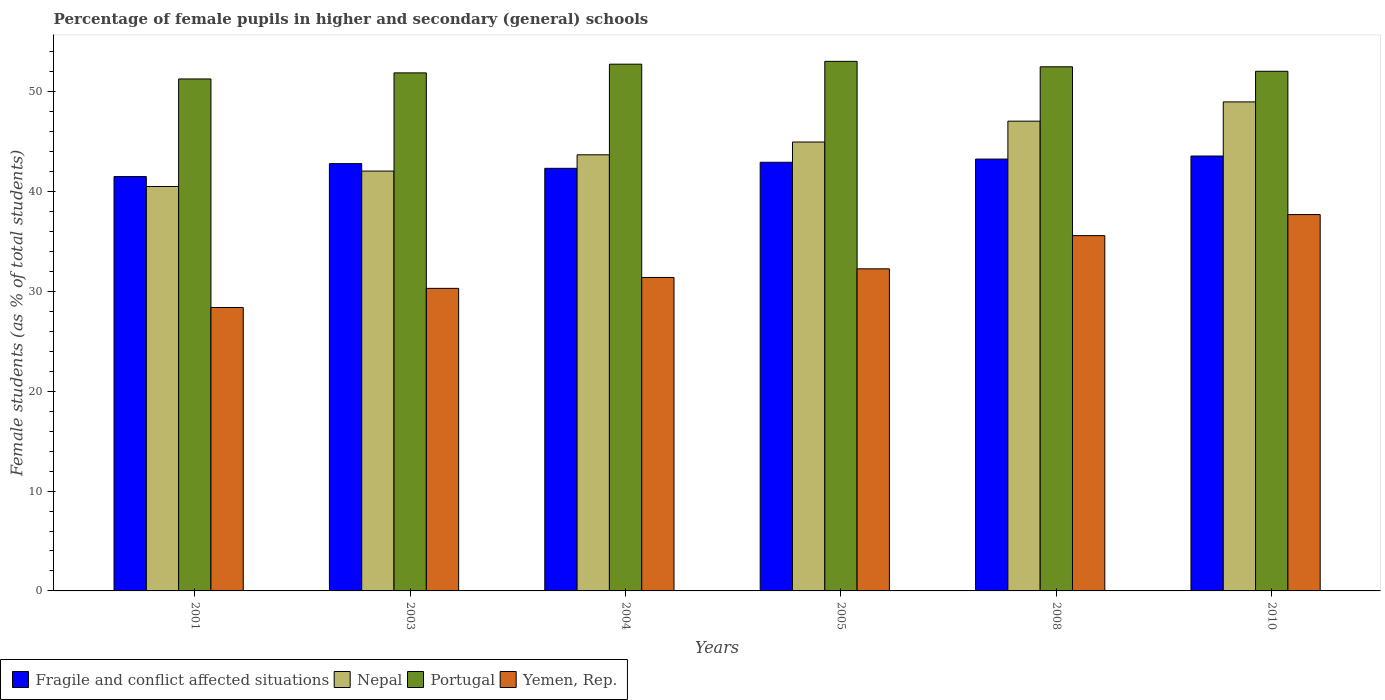How many different coloured bars are there?
Your response must be concise. 4. How many groups of bars are there?
Offer a terse response. 6. How many bars are there on the 3rd tick from the left?
Give a very brief answer. 4. How many bars are there on the 3rd tick from the right?
Offer a terse response. 4. What is the percentage of female pupils in higher and secondary schools in Nepal in 2003?
Ensure brevity in your answer.  42.04. Across all years, what is the maximum percentage of female pupils in higher and secondary schools in Nepal?
Offer a terse response. 48.97. Across all years, what is the minimum percentage of female pupils in higher and secondary schools in Nepal?
Your response must be concise. 40.5. In which year was the percentage of female pupils in higher and secondary schools in Nepal maximum?
Provide a short and direct response. 2010. What is the total percentage of female pupils in higher and secondary schools in Yemen, Rep. in the graph?
Provide a short and direct response. 195.58. What is the difference between the percentage of female pupils in higher and secondary schools in Yemen, Rep. in 2003 and that in 2010?
Offer a terse response. -7.39. What is the difference between the percentage of female pupils in higher and secondary schools in Yemen, Rep. in 2010 and the percentage of female pupils in higher and secondary schools in Portugal in 2005?
Ensure brevity in your answer.  -15.34. What is the average percentage of female pupils in higher and secondary schools in Yemen, Rep. per year?
Keep it short and to the point. 32.6. In the year 2010, what is the difference between the percentage of female pupils in higher and secondary schools in Nepal and percentage of female pupils in higher and secondary schools in Yemen, Rep.?
Offer a terse response. 11.28. In how many years, is the percentage of female pupils in higher and secondary schools in Fragile and conflict affected situations greater than 26 %?
Keep it short and to the point. 6. What is the ratio of the percentage of female pupils in higher and secondary schools in Nepal in 2003 to that in 2008?
Offer a very short reply. 0.89. What is the difference between the highest and the second highest percentage of female pupils in higher and secondary schools in Nepal?
Offer a very short reply. 1.93. What is the difference between the highest and the lowest percentage of female pupils in higher and secondary schools in Portugal?
Ensure brevity in your answer.  1.76. In how many years, is the percentage of female pupils in higher and secondary schools in Portugal greater than the average percentage of female pupils in higher and secondary schools in Portugal taken over all years?
Provide a succinct answer. 3. What does the 4th bar from the left in 2008 represents?
Provide a short and direct response. Yemen, Rep. What does the 1st bar from the right in 2010 represents?
Offer a terse response. Yemen, Rep. Is it the case that in every year, the sum of the percentage of female pupils in higher and secondary schools in Nepal and percentage of female pupils in higher and secondary schools in Fragile and conflict affected situations is greater than the percentage of female pupils in higher and secondary schools in Portugal?
Provide a short and direct response. Yes. How many bars are there?
Your response must be concise. 24. Are all the bars in the graph horizontal?
Offer a terse response. No. How many years are there in the graph?
Your answer should be very brief. 6. Are the values on the major ticks of Y-axis written in scientific E-notation?
Keep it short and to the point. No. Does the graph contain grids?
Your response must be concise. No. What is the title of the graph?
Offer a very short reply. Percentage of female pupils in higher and secondary (general) schools. Does "Afghanistan" appear as one of the legend labels in the graph?
Provide a succinct answer. No. What is the label or title of the X-axis?
Your answer should be very brief. Years. What is the label or title of the Y-axis?
Provide a short and direct response. Female students (as % of total students). What is the Female students (as % of total students) of Fragile and conflict affected situations in 2001?
Provide a short and direct response. 41.49. What is the Female students (as % of total students) of Nepal in 2001?
Make the answer very short. 40.5. What is the Female students (as % of total students) of Portugal in 2001?
Ensure brevity in your answer.  51.26. What is the Female students (as % of total students) of Yemen, Rep. in 2001?
Provide a succinct answer. 28.38. What is the Female students (as % of total students) in Fragile and conflict affected situations in 2003?
Your answer should be very brief. 42.79. What is the Female students (as % of total students) of Nepal in 2003?
Provide a short and direct response. 42.04. What is the Female students (as % of total students) of Portugal in 2003?
Keep it short and to the point. 51.87. What is the Female students (as % of total students) in Yemen, Rep. in 2003?
Give a very brief answer. 30.3. What is the Female students (as % of total students) of Fragile and conflict affected situations in 2004?
Keep it short and to the point. 42.32. What is the Female students (as % of total students) in Nepal in 2004?
Your answer should be compact. 43.67. What is the Female students (as % of total students) of Portugal in 2004?
Keep it short and to the point. 52.74. What is the Female students (as % of total students) of Yemen, Rep. in 2004?
Keep it short and to the point. 31.39. What is the Female students (as % of total students) in Fragile and conflict affected situations in 2005?
Give a very brief answer. 42.92. What is the Female students (as % of total students) of Nepal in 2005?
Your response must be concise. 44.95. What is the Female students (as % of total students) in Portugal in 2005?
Provide a succinct answer. 53.03. What is the Female students (as % of total students) in Yemen, Rep. in 2005?
Your response must be concise. 32.25. What is the Female students (as % of total students) in Fragile and conflict affected situations in 2008?
Your answer should be compact. 43.24. What is the Female students (as % of total students) of Nepal in 2008?
Offer a very short reply. 47.04. What is the Female students (as % of total students) in Portugal in 2008?
Keep it short and to the point. 52.48. What is the Female students (as % of total students) of Yemen, Rep. in 2008?
Ensure brevity in your answer.  35.58. What is the Female students (as % of total students) of Fragile and conflict affected situations in 2010?
Offer a terse response. 43.55. What is the Female students (as % of total students) in Nepal in 2010?
Ensure brevity in your answer.  48.97. What is the Female students (as % of total students) of Portugal in 2010?
Keep it short and to the point. 52.03. What is the Female students (as % of total students) in Yemen, Rep. in 2010?
Provide a succinct answer. 37.69. Across all years, what is the maximum Female students (as % of total students) in Fragile and conflict affected situations?
Provide a succinct answer. 43.55. Across all years, what is the maximum Female students (as % of total students) of Nepal?
Your answer should be compact. 48.97. Across all years, what is the maximum Female students (as % of total students) in Portugal?
Give a very brief answer. 53.03. Across all years, what is the maximum Female students (as % of total students) of Yemen, Rep.?
Your response must be concise. 37.69. Across all years, what is the minimum Female students (as % of total students) in Fragile and conflict affected situations?
Your answer should be compact. 41.49. Across all years, what is the minimum Female students (as % of total students) of Nepal?
Your answer should be very brief. 40.5. Across all years, what is the minimum Female students (as % of total students) in Portugal?
Offer a terse response. 51.26. Across all years, what is the minimum Female students (as % of total students) in Yemen, Rep.?
Give a very brief answer. 28.38. What is the total Female students (as % of total students) of Fragile and conflict affected situations in the graph?
Ensure brevity in your answer.  256.31. What is the total Female students (as % of total students) of Nepal in the graph?
Ensure brevity in your answer.  267.16. What is the total Female students (as % of total students) in Portugal in the graph?
Make the answer very short. 313.43. What is the total Female students (as % of total students) in Yemen, Rep. in the graph?
Offer a terse response. 195.58. What is the difference between the Female students (as % of total students) in Fragile and conflict affected situations in 2001 and that in 2003?
Provide a succinct answer. -1.29. What is the difference between the Female students (as % of total students) of Nepal in 2001 and that in 2003?
Provide a succinct answer. -1.54. What is the difference between the Female students (as % of total students) in Portugal in 2001 and that in 2003?
Provide a succinct answer. -0.61. What is the difference between the Female students (as % of total students) in Yemen, Rep. in 2001 and that in 2003?
Provide a short and direct response. -1.92. What is the difference between the Female students (as % of total students) in Fragile and conflict affected situations in 2001 and that in 2004?
Ensure brevity in your answer.  -0.82. What is the difference between the Female students (as % of total students) in Nepal in 2001 and that in 2004?
Provide a succinct answer. -3.17. What is the difference between the Female students (as % of total students) in Portugal in 2001 and that in 2004?
Ensure brevity in your answer.  -1.48. What is the difference between the Female students (as % of total students) in Yemen, Rep. in 2001 and that in 2004?
Offer a terse response. -3.01. What is the difference between the Female students (as % of total students) in Fragile and conflict affected situations in 2001 and that in 2005?
Your answer should be very brief. -1.43. What is the difference between the Female students (as % of total students) in Nepal in 2001 and that in 2005?
Ensure brevity in your answer.  -4.45. What is the difference between the Female students (as % of total students) of Portugal in 2001 and that in 2005?
Make the answer very short. -1.76. What is the difference between the Female students (as % of total students) of Yemen, Rep. in 2001 and that in 2005?
Offer a very short reply. -3.87. What is the difference between the Female students (as % of total students) of Fragile and conflict affected situations in 2001 and that in 2008?
Your response must be concise. -1.75. What is the difference between the Female students (as % of total students) in Nepal in 2001 and that in 2008?
Provide a short and direct response. -6.54. What is the difference between the Female students (as % of total students) of Portugal in 2001 and that in 2008?
Your response must be concise. -1.22. What is the difference between the Female students (as % of total students) of Yemen, Rep. in 2001 and that in 2008?
Give a very brief answer. -7.2. What is the difference between the Female students (as % of total students) of Fragile and conflict affected situations in 2001 and that in 2010?
Offer a terse response. -2.06. What is the difference between the Female students (as % of total students) of Nepal in 2001 and that in 2010?
Offer a terse response. -8.47. What is the difference between the Female students (as % of total students) of Portugal in 2001 and that in 2010?
Your response must be concise. -0.77. What is the difference between the Female students (as % of total students) in Yemen, Rep. in 2001 and that in 2010?
Your response must be concise. -9.31. What is the difference between the Female students (as % of total students) of Fragile and conflict affected situations in 2003 and that in 2004?
Offer a very short reply. 0.47. What is the difference between the Female students (as % of total students) of Nepal in 2003 and that in 2004?
Your answer should be very brief. -1.63. What is the difference between the Female students (as % of total students) of Portugal in 2003 and that in 2004?
Your answer should be very brief. -0.87. What is the difference between the Female students (as % of total students) of Yemen, Rep. in 2003 and that in 2004?
Give a very brief answer. -1.09. What is the difference between the Female students (as % of total students) in Fragile and conflict affected situations in 2003 and that in 2005?
Provide a short and direct response. -0.13. What is the difference between the Female students (as % of total students) in Nepal in 2003 and that in 2005?
Keep it short and to the point. -2.91. What is the difference between the Female students (as % of total students) in Portugal in 2003 and that in 2005?
Keep it short and to the point. -1.15. What is the difference between the Female students (as % of total students) in Yemen, Rep. in 2003 and that in 2005?
Offer a terse response. -1.96. What is the difference between the Female students (as % of total students) of Fragile and conflict affected situations in 2003 and that in 2008?
Keep it short and to the point. -0.46. What is the difference between the Female students (as % of total students) of Nepal in 2003 and that in 2008?
Your answer should be compact. -5. What is the difference between the Female students (as % of total students) of Portugal in 2003 and that in 2008?
Make the answer very short. -0.61. What is the difference between the Female students (as % of total students) of Yemen, Rep. in 2003 and that in 2008?
Offer a very short reply. -5.28. What is the difference between the Female students (as % of total students) of Fragile and conflict affected situations in 2003 and that in 2010?
Your answer should be very brief. -0.76. What is the difference between the Female students (as % of total students) in Nepal in 2003 and that in 2010?
Ensure brevity in your answer.  -6.93. What is the difference between the Female students (as % of total students) in Portugal in 2003 and that in 2010?
Provide a short and direct response. -0.16. What is the difference between the Female students (as % of total students) in Yemen, Rep. in 2003 and that in 2010?
Your response must be concise. -7.39. What is the difference between the Female students (as % of total students) of Fragile and conflict affected situations in 2004 and that in 2005?
Your answer should be compact. -0.6. What is the difference between the Female students (as % of total students) of Nepal in 2004 and that in 2005?
Offer a terse response. -1.28. What is the difference between the Female students (as % of total students) in Portugal in 2004 and that in 2005?
Your response must be concise. -0.28. What is the difference between the Female students (as % of total students) of Yemen, Rep. in 2004 and that in 2005?
Your answer should be very brief. -0.86. What is the difference between the Female students (as % of total students) of Fragile and conflict affected situations in 2004 and that in 2008?
Your answer should be very brief. -0.93. What is the difference between the Female students (as % of total students) in Nepal in 2004 and that in 2008?
Offer a very short reply. -3.37. What is the difference between the Female students (as % of total students) in Portugal in 2004 and that in 2008?
Keep it short and to the point. 0.26. What is the difference between the Female students (as % of total students) in Yemen, Rep. in 2004 and that in 2008?
Keep it short and to the point. -4.19. What is the difference between the Female students (as % of total students) of Fragile and conflict affected situations in 2004 and that in 2010?
Make the answer very short. -1.23. What is the difference between the Female students (as % of total students) of Nepal in 2004 and that in 2010?
Provide a short and direct response. -5.3. What is the difference between the Female students (as % of total students) in Portugal in 2004 and that in 2010?
Your answer should be compact. 0.71. What is the difference between the Female students (as % of total students) in Yemen, Rep. in 2004 and that in 2010?
Offer a very short reply. -6.3. What is the difference between the Female students (as % of total students) of Fragile and conflict affected situations in 2005 and that in 2008?
Ensure brevity in your answer.  -0.32. What is the difference between the Female students (as % of total students) in Nepal in 2005 and that in 2008?
Provide a short and direct response. -2.09. What is the difference between the Female students (as % of total students) of Portugal in 2005 and that in 2008?
Keep it short and to the point. 0.54. What is the difference between the Female students (as % of total students) in Yemen, Rep. in 2005 and that in 2008?
Provide a succinct answer. -3.32. What is the difference between the Female students (as % of total students) in Fragile and conflict affected situations in 2005 and that in 2010?
Provide a short and direct response. -0.63. What is the difference between the Female students (as % of total students) of Nepal in 2005 and that in 2010?
Provide a short and direct response. -4.02. What is the difference between the Female students (as % of total students) in Yemen, Rep. in 2005 and that in 2010?
Ensure brevity in your answer.  -5.43. What is the difference between the Female students (as % of total students) of Fragile and conflict affected situations in 2008 and that in 2010?
Make the answer very short. -0.31. What is the difference between the Female students (as % of total students) of Nepal in 2008 and that in 2010?
Provide a short and direct response. -1.93. What is the difference between the Female students (as % of total students) in Portugal in 2008 and that in 2010?
Your answer should be very brief. 0.45. What is the difference between the Female students (as % of total students) of Yemen, Rep. in 2008 and that in 2010?
Your response must be concise. -2.11. What is the difference between the Female students (as % of total students) of Fragile and conflict affected situations in 2001 and the Female students (as % of total students) of Nepal in 2003?
Offer a very short reply. -0.55. What is the difference between the Female students (as % of total students) of Fragile and conflict affected situations in 2001 and the Female students (as % of total students) of Portugal in 2003?
Make the answer very short. -10.38. What is the difference between the Female students (as % of total students) in Fragile and conflict affected situations in 2001 and the Female students (as % of total students) in Yemen, Rep. in 2003?
Offer a terse response. 11.2. What is the difference between the Female students (as % of total students) in Nepal in 2001 and the Female students (as % of total students) in Portugal in 2003?
Ensure brevity in your answer.  -11.38. What is the difference between the Female students (as % of total students) in Nepal in 2001 and the Female students (as % of total students) in Yemen, Rep. in 2003?
Give a very brief answer. 10.2. What is the difference between the Female students (as % of total students) in Portugal in 2001 and the Female students (as % of total students) in Yemen, Rep. in 2003?
Provide a succinct answer. 20.97. What is the difference between the Female students (as % of total students) of Fragile and conflict affected situations in 2001 and the Female students (as % of total students) of Nepal in 2004?
Make the answer very short. -2.18. What is the difference between the Female students (as % of total students) of Fragile and conflict affected situations in 2001 and the Female students (as % of total students) of Portugal in 2004?
Your answer should be very brief. -11.25. What is the difference between the Female students (as % of total students) of Fragile and conflict affected situations in 2001 and the Female students (as % of total students) of Yemen, Rep. in 2004?
Ensure brevity in your answer.  10.1. What is the difference between the Female students (as % of total students) of Nepal in 2001 and the Female students (as % of total students) of Portugal in 2004?
Give a very brief answer. -12.25. What is the difference between the Female students (as % of total students) in Nepal in 2001 and the Female students (as % of total students) in Yemen, Rep. in 2004?
Keep it short and to the point. 9.11. What is the difference between the Female students (as % of total students) in Portugal in 2001 and the Female students (as % of total students) in Yemen, Rep. in 2004?
Provide a short and direct response. 19.88. What is the difference between the Female students (as % of total students) in Fragile and conflict affected situations in 2001 and the Female students (as % of total students) in Nepal in 2005?
Offer a very short reply. -3.46. What is the difference between the Female students (as % of total students) in Fragile and conflict affected situations in 2001 and the Female students (as % of total students) in Portugal in 2005?
Your answer should be very brief. -11.54. What is the difference between the Female students (as % of total students) of Fragile and conflict affected situations in 2001 and the Female students (as % of total students) of Yemen, Rep. in 2005?
Keep it short and to the point. 9.24. What is the difference between the Female students (as % of total students) in Nepal in 2001 and the Female students (as % of total students) in Portugal in 2005?
Your answer should be very brief. -12.53. What is the difference between the Female students (as % of total students) of Nepal in 2001 and the Female students (as % of total students) of Yemen, Rep. in 2005?
Your response must be concise. 8.24. What is the difference between the Female students (as % of total students) in Portugal in 2001 and the Female students (as % of total students) in Yemen, Rep. in 2005?
Provide a short and direct response. 19.01. What is the difference between the Female students (as % of total students) in Fragile and conflict affected situations in 2001 and the Female students (as % of total students) in Nepal in 2008?
Keep it short and to the point. -5.55. What is the difference between the Female students (as % of total students) in Fragile and conflict affected situations in 2001 and the Female students (as % of total students) in Portugal in 2008?
Make the answer very short. -10.99. What is the difference between the Female students (as % of total students) in Fragile and conflict affected situations in 2001 and the Female students (as % of total students) in Yemen, Rep. in 2008?
Offer a very short reply. 5.92. What is the difference between the Female students (as % of total students) of Nepal in 2001 and the Female students (as % of total students) of Portugal in 2008?
Give a very brief answer. -11.99. What is the difference between the Female students (as % of total students) in Nepal in 2001 and the Female students (as % of total students) in Yemen, Rep. in 2008?
Keep it short and to the point. 4.92. What is the difference between the Female students (as % of total students) in Portugal in 2001 and the Female students (as % of total students) in Yemen, Rep. in 2008?
Ensure brevity in your answer.  15.69. What is the difference between the Female students (as % of total students) of Fragile and conflict affected situations in 2001 and the Female students (as % of total students) of Nepal in 2010?
Make the answer very short. -7.47. What is the difference between the Female students (as % of total students) of Fragile and conflict affected situations in 2001 and the Female students (as % of total students) of Portugal in 2010?
Your response must be concise. -10.54. What is the difference between the Female students (as % of total students) in Fragile and conflict affected situations in 2001 and the Female students (as % of total students) in Yemen, Rep. in 2010?
Your answer should be compact. 3.81. What is the difference between the Female students (as % of total students) in Nepal in 2001 and the Female students (as % of total students) in Portugal in 2010?
Offer a very short reply. -11.54. What is the difference between the Female students (as % of total students) of Nepal in 2001 and the Female students (as % of total students) of Yemen, Rep. in 2010?
Offer a terse response. 2.81. What is the difference between the Female students (as % of total students) in Portugal in 2001 and the Female students (as % of total students) in Yemen, Rep. in 2010?
Offer a very short reply. 13.58. What is the difference between the Female students (as % of total students) of Fragile and conflict affected situations in 2003 and the Female students (as % of total students) of Nepal in 2004?
Provide a succinct answer. -0.88. What is the difference between the Female students (as % of total students) in Fragile and conflict affected situations in 2003 and the Female students (as % of total students) in Portugal in 2004?
Your response must be concise. -9.96. What is the difference between the Female students (as % of total students) in Fragile and conflict affected situations in 2003 and the Female students (as % of total students) in Yemen, Rep. in 2004?
Offer a very short reply. 11.4. What is the difference between the Female students (as % of total students) in Nepal in 2003 and the Female students (as % of total students) in Portugal in 2004?
Offer a very short reply. -10.7. What is the difference between the Female students (as % of total students) in Nepal in 2003 and the Female students (as % of total students) in Yemen, Rep. in 2004?
Provide a succinct answer. 10.65. What is the difference between the Female students (as % of total students) in Portugal in 2003 and the Female students (as % of total students) in Yemen, Rep. in 2004?
Provide a short and direct response. 20.48. What is the difference between the Female students (as % of total students) of Fragile and conflict affected situations in 2003 and the Female students (as % of total students) of Nepal in 2005?
Offer a terse response. -2.16. What is the difference between the Female students (as % of total students) of Fragile and conflict affected situations in 2003 and the Female students (as % of total students) of Portugal in 2005?
Give a very brief answer. -10.24. What is the difference between the Female students (as % of total students) in Fragile and conflict affected situations in 2003 and the Female students (as % of total students) in Yemen, Rep. in 2005?
Offer a terse response. 10.53. What is the difference between the Female students (as % of total students) in Nepal in 2003 and the Female students (as % of total students) in Portugal in 2005?
Your response must be concise. -10.99. What is the difference between the Female students (as % of total students) of Nepal in 2003 and the Female students (as % of total students) of Yemen, Rep. in 2005?
Provide a short and direct response. 9.79. What is the difference between the Female students (as % of total students) of Portugal in 2003 and the Female students (as % of total students) of Yemen, Rep. in 2005?
Offer a very short reply. 19.62. What is the difference between the Female students (as % of total students) of Fragile and conflict affected situations in 2003 and the Female students (as % of total students) of Nepal in 2008?
Provide a short and direct response. -4.25. What is the difference between the Female students (as % of total students) of Fragile and conflict affected situations in 2003 and the Female students (as % of total students) of Portugal in 2008?
Offer a terse response. -9.7. What is the difference between the Female students (as % of total students) of Fragile and conflict affected situations in 2003 and the Female students (as % of total students) of Yemen, Rep. in 2008?
Provide a succinct answer. 7.21. What is the difference between the Female students (as % of total students) in Nepal in 2003 and the Female students (as % of total students) in Portugal in 2008?
Keep it short and to the point. -10.44. What is the difference between the Female students (as % of total students) in Nepal in 2003 and the Female students (as % of total students) in Yemen, Rep. in 2008?
Keep it short and to the point. 6.46. What is the difference between the Female students (as % of total students) of Portugal in 2003 and the Female students (as % of total students) of Yemen, Rep. in 2008?
Keep it short and to the point. 16.3. What is the difference between the Female students (as % of total students) of Fragile and conflict affected situations in 2003 and the Female students (as % of total students) of Nepal in 2010?
Your answer should be compact. -6.18. What is the difference between the Female students (as % of total students) in Fragile and conflict affected situations in 2003 and the Female students (as % of total students) in Portugal in 2010?
Offer a very short reply. -9.25. What is the difference between the Female students (as % of total students) in Fragile and conflict affected situations in 2003 and the Female students (as % of total students) in Yemen, Rep. in 2010?
Your answer should be very brief. 5.1. What is the difference between the Female students (as % of total students) of Nepal in 2003 and the Female students (as % of total students) of Portugal in 2010?
Provide a succinct answer. -9.99. What is the difference between the Female students (as % of total students) of Nepal in 2003 and the Female students (as % of total students) of Yemen, Rep. in 2010?
Ensure brevity in your answer.  4.36. What is the difference between the Female students (as % of total students) of Portugal in 2003 and the Female students (as % of total students) of Yemen, Rep. in 2010?
Your answer should be very brief. 14.19. What is the difference between the Female students (as % of total students) in Fragile and conflict affected situations in 2004 and the Female students (as % of total students) in Nepal in 2005?
Provide a short and direct response. -2.63. What is the difference between the Female students (as % of total students) of Fragile and conflict affected situations in 2004 and the Female students (as % of total students) of Portugal in 2005?
Provide a short and direct response. -10.71. What is the difference between the Female students (as % of total students) of Fragile and conflict affected situations in 2004 and the Female students (as % of total students) of Yemen, Rep. in 2005?
Give a very brief answer. 10.06. What is the difference between the Female students (as % of total students) of Nepal in 2004 and the Female students (as % of total students) of Portugal in 2005?
Your answer should be compact. -9.36. What is the difference between the Female students (as % of total students) in Nepal in 2004 and the Female students (as % of total students) in Yemen, Rep. in 2005?
Your response must be concise. 11.42. What is the difference between the Female students (as % of total students) of Portugal in 2004 and the Female students (as % of total students) of Yemen, Rep. in 2005?
Give a very brief answer. 20.49. What is the difference between the Female students (as % of total students) in Fragile and conflict affected situations in 2004 and the Female students (as % of total students) in Nepal in 2008?
Your answer should be very brief. -4.72. What is the difference between the Female students (as % of total students) in Fragile and conflict affected situations in 2004 and the Female students (as % of total students) in Portugal in 2008?
Give a very brief answer. -10.17. What is the difference between the Female students (as % of total students) of Fragile and conflict affected situations in 2004 and the Female students (as % of total students) of Yemen, Rep. in 2008?
Ensure brevity in your answer.  6.74. What is the difference between the Female students (as % of total students) of Nepal in 2004 and the Female students (as % of total students) of Portugal in 2008?
Keep it short and to the point. -8.81. What is the difference between the Female students (as % of total students) in Nepal in 2004 and the Female students (as % of total students) in Yemen, Rep. in 2008?
Offer a terse response. 8.09. What is the difference between the Female students (as % of total students) in Portugal in 2004 and the Female students (as % of total students) in Yemen, Rep. in 2008?
Provide a short and direct response. 17.17. What is the difference between the Female students (as % of total students) of Fragile and conflict affected situations in 2004 and the Female students (as % of total students) of Nepal in 2010?
Your response must be concise. -6.65. What is the difference between the Female students (as % of total students) of Fragile and conflict affected situations in 2004 and the Female students (as % of total students) of Portugal in 2010?
Your answer should be compact. -9.72. What is the difference between the Female students (as % of total students) in Fragile and conflict affected situations in 2004 and the Female students (as % of total students) in Yemen, Rep. in 2010?
Provide a short and direct response. 4.63. What is the difference between the Female students (as % of total students) in Nepal in 2004 and the Female students (as % of total students) in Portugal in 2010?
Provide a short and direct response. -8.36. What is the difference between the Female students (as % of total students) in Nepal in 2004 and the Female students (as % of total students) in Yemen, Rep. in 2010?
Your answer should be very brief. 5.98. What is the difference between the Female students (as % of total students) in Portugal in 2004 and the Female students (as % of total students) in Yemen, Rep. in 2010?
Keep it short and to the point. 15.06. What is the difference between the Female students (as % of total students) in Fragile and conflict affected situations in 2005 and the Female students (as % of total students) in Nepal in 2008?
Ensure brevity in your answer.  -4.12. What is the difference between the Female students (as % of total students) of Fragile and conflict affected situations in 2005 and the Female students (as % of total students) of Portugal in 2008?
Offer a very short reply. -9.56. What is the difference between the Female students (as % of total students) in Fragile and conflict affected situations in 2005 and the Female students (as % of total students) in Yemen, Rep. in 2008?
Provide a succinct answer. 7.35. What is the difference between the Female students (as % of total students) in Nepal in 2005 and the Female students (as % of total students) in Portugal in 2008?
Give a very brief answer. -7.53. What is the difference between the Female students (as % of total students) of Nepal in 2005 and the Female students (as % of total students) of Yemen, Rep. in 2008?
Give a very brief answer. 9.37. What is the difference between the Female students (as % of total students) of Portugal in 2005 and the Female students (as % of total students) of Yemen, Rep. in 2008?
Ensure brevity in your answer.  17.45. What is the difference between the Female students (as % of total students) of Fragile and conflict affected situations in 2005 and the Female students (as % of total students) of Nepal in 2010?
Your answer should be compact. -6.05. What is the difference between the Female students (as % of total students) in Fragile and conflict affected situations in 2005 and the Female students (as % of total students) in Portugal in 2010?
Offer a terse response. -9.11. What is the difference between the Female students (as % of total students) in Fragile and conflict affected situations in 2005 and the Female students (as % of total students) in Yemen, Rep. in 2010?
Keep it short and to the point. 5.24. What is the difference between the Female students (as % of total students) in Nepal in 2005 and the Female students (as % of total students) in Portugal in 2010?
Give a very brief answer. -7.08. What is the difference between the Female students (as % of total students) of Nepal in 2005 and the Female students (as % of total students) of Yemen, Rep. in 2010?
Provide a short and direct response. 7.26. What is the difference between the Female students (as % of total students) in Portugal in 2005 and the Female students (as % of total students) in Yemen, Rep. in 2010?
Offer a terse response. 15.34. What is the difference between the Female students (as % of total students) in Fragile and conflict affected situations in 2008 and the Female students (as % of total students) in Nepal in 2010?
Provide a short and direct response. -5.72. What is the difference between the Female students (as % of total students) of Fragile and conflict affected situations in 2008 and the Female students (as % of total students) of Portugal in 2010?
Ensure brevity in your answer.  -8.79. What is the difference between the Female students (as % of total students) in Fragile and conflict affected situations in 2008 and the Female students (as % of total students) in Yemen, Rep. in 2010?
Make the answer very short. 5.56. What is the difference between the Female students (as % of total students) in Nepal in 2008 and the Female students (as % of total students) in Portugal in 2010?
Provide a short and direct response. -5. What is the difference between the Female students (as % of total students) of Nepal in 2008 and the Female students (as % of total students) of Yemen, Rep. in 2010?
Provide a short and direct response. 9.35. What is the difference between the Female students (as % of total students) in Portugal in 2008 and the Female students (as % of total students) in Yemen, Rep. in 2010?
Provide a succinct answer. 14.8. What is the average Female students (as % of total students) of Fragile and conflict affected situations per year?
Provide a short and direct response. 42.72. What is the average Female students (as % of total students) in Nepal per year?
Provide a short and direct response. 44.53. What is the average Female students (as % of total students) of Portugal per year?
Keep it short and to the point. 52.24. What is the average Female students (as % of total students) of Yemen, Rep. per year?
Give a very brief answer. 32.6. In the year 2001, what is the difference between the Female students (as % of total students) of Fragile and conflict affected situations and Female students (as % of total students) of Portugal?
Ensure brevity in your answer.  -9.77. In the year 2001, what is the difference between the Female students (as % of total students) of Fragile and conflict affected situations and Female students (as % of total students) of Yemen, Rep.?
Your response must be concise. 13.11. In the year 2001, what is the difference between the Female students (as % of total students) of Nepal and Female students (as % of total students) of Portugal?
Keep it short and to the point. -10.77. In the year 2001, what is the difference between the Female students (as % of total students) in Nepal and Female students (as % of total students) in Yemen, Rep.?
Ensure brevity in your answer.  12.12. In the year 2001, what is the difference between the Female students (as % of total students) in Portugal and Female students (as % of total students) in Yemen, Rep.?
Your answer should be very brief. 22.88. In the year 2003, what is the difference between the Female students (as % of total students) in Fragile and conflict affected situations and Female students (as % of total students) in Nepal?
Provide a succinct answer. 0.75. In the year 2003, what is the difference between the Female students (as % of total students) of Fragile and conflict affected situations and Female students (as % of total students) of Portugal?
Your answer should be compact. -9.09. In the year 2003, what is the difference between the Female students (as % of total students) in Fragile and conflict affected situations and Female students (as % of total students) in Yemen, Rep.?
Offer a very short reply. 12.49. In the year 2003, what is the difference between the Female students (as % of total students) of Nepal and Female students (as % of total students) of Portugal?
Provide a succinct answer. -9.83. In the year 2003, what is the difference between the Female students (as % of total students) in Nepal and Female students (as % of total students) in Yemen, Rep.?
Provide a succinct answer. 11.74. In the year 2003, what is the difference between the Female students (as % of total students) in Portugal and Female students (as % of total students) in Yemen, Rep.?
Provide a succinct answer. 21.58. In the year 2004, what is the difference between the Female students (as % of total students) of Fragile and conflict affected situations and Female students (as % of total students) of Nepal?
Keep it short and to the point. -1.35. In the year 2004, what is the difference between the Female students (as % of total students) in Fragile and conflict affected situations and Female students (as % of total students) in Portugal?
Your answer should be compact. -10.43. In the year 2004, what is the difference between the Female students (as % of total students) of Fragile and conflict affected situations and Female students (as % of total students) of Yemen, Rep.?
Keep it short and to the point. 10.93. In the year 2004, what is the difference between the Female students (as % of total students) in Nepal and Female students (as % of total students) in Portugal?
Your answer should be compact. -9.07. In the year 2004, what is the difference between the Female students (as % of total students) of Nepal and Female students (as % of total students) of Yemen, Rep.?
Provide a succinct answer. 12.28. In the year 2004, what is the difference between the Female students (as % of total students) in Portugal and Female students (as % of total students) in Yemen, Rep.?
Offer a terse response. 21.36. In the year 2005, what is the difference between the Female students (as % of total students) in Fragile and conflict affected situations and Female students (as % of total students) in Nepal?
Make the answer very short. -2.03. In the year 2005, what is the difference between the Female students (as % of total students) in Fragile and conflict affected situations and Female students (as % of total students) in Portugal?
Your answer should be very brief. -10.11. In the year 2005, what is the difference between the Female students (as % of total students) of Fragile and conflict affected situations and Female students (as % of total students) of Yemen, Rep.?
Your response must be concise. 10.67. In the year 2005, what is the difference between the Female students (as % of total students) of Nepal and Female students (as % of total students) of Portugal?
Your response must be concise. -8.08. In the year 2005, what is the difference between the Female students (as % of total students) in Nepal and Female students (as % of total students) in Yemen, Rep.?
Your answer should be very brief. 12.7. In the year 2005, what is the difference between the Female students (as % of total students) in Portugal and Female students (as % of total students) in Yemen, Rep.?
Your answer should be very brief. 20.77. In the year 2008, what is the difference between the Female students (as % of total students) in Fragile and conflict affected situations and Female students (as % of total students) in Nepal?
Provide a short and direct response. -3.8. In the year 2008, what is the difference between the Female students (as % of total students) in Fragile and conflict affected situations and Female students (as % of total students) in Portugal?
Your answer should be compact. -9.24. In the year 2008, what is the difference between the Female students (as % of total students) of Fragile and conflict affected situations and Female students (as % of total students) of Yemen, Rep.?
Your response must be concise. 7.67. In the year 2008, what is the difference between the Female students (as % of total students) in Nepal and Female students (as % of total students) in Portugal?
Keep it short and to the point. -5.44. In the year 2008, what is the difference between the Female students (as % of total students) in Nepal and Female students (as % of total students) in Yemen, Rep.?
Offer a terse response. 11.46. In the year 2008, what is the difference between the Female students (as % of total students) in Portugal and Female students (as % of total students) in Yemen, Rep.?
Ensure brevity in your answer.  16.91. In the year 2010, what is the difference between the Female students (as % of total students) of Fragile and conflict affected situations and Female students (as % of total students) of Nepal?
Keep it short and to the point. -5.42. In the year 2010, what is the difference between the Female students (as % of total students) of Fragile and conflict affected situations and Female students (as % of total students) of Portugal?
Provide a short and direct response. -8.49. In the year 2010, what is the difference between the Female students (as % of total students) in Fragile and conflict affected situations and Female students (as % of total students) in Yemen, Rep.?
Ensure brevity in your answer.  5.86. In the year 2010, what is the difference between the Female students (as % of total students) of Nepal and Female students (as % of total students) of Portugal?
Keep it short and to the point. -3.07. In the year 2010, what is the difference between the Female students (as % of total students) in Nepal and Female students (as % of total students) in Yemen, Rep.?
Give a very brief answer. 11.28. In the year 2010, what is the difference between the Female students (as % of total students) in Portugal and Female students (as % of total students) in Yemen, Rep.?
Give a very brief answer. 14.35. What is the ratio of the Female students (as % of total students) in Fragile and conflict affected situations in 2001 to that in 2003?
Ensure brevity in your answer.  0.97. What is the ratio of the Female students (as % of total students) in Nepal in 2001 to that in 2003?
Ensure brevity in your answer.  0.96. What is the ratio of the Female students (as % of total students) of Portugal in 2001 to that in 2003?
Offer a terse response. 0.99. What is the ratio of the Female students (as % of total students) of Yemen, Rep. in 2001 to that in 2003?
Your answer should be compact. 0.94. What is the ratio of the Female students (as % of total students) of Fragile and conflict affected situations in 2001 to that in 2004?
Your response must be concise. 0.98. What is the ratio of the Female students (as % of total students) in Nepal in 2001 to that in 2004?
Give a very brief answer. 0.93. What is the ratio of the Female students (as % of total students) in Portugal in 2001 to that in 2004?
Offer a very short reply. 0.97. What is the ratio of the Female students (as % of total students) of Yemen, Rep. in 2001 to that in 2004?
Provide a short and direct response. 0.9. What is the ratio of the Female students (as % of total students) of Fragile and conflict affected situations in 2001 to that in 2005?
Provide a short and direct response. 0.97. What is the ratio of the Female students (as % of total students) in Nepal in 2001 to that in 2005?
Offer a very short reply. 0.9. What is the ratio of the Female students (as % of total students) in Portugal in 2001 to that in 2005?
Make the answer very short. 0.97. What is the ratio of the Female students (as % of total students) in Yemen, Rep. in 2001 to that in 2005?
Your answer should be very brief. 0.88. What is the ratio of the Female students (as % of total students) of Fragile and conflict affected situations in 2001 to that in 2008?
Offer a very short reply. 0.96. What is the ratio of the Female students (as % of total students) of Nepal in 2001 to that in 2008?
Give a very brief answer. 0.86. What is the ratio of the Female students (as % of total students) of Portugal in 2001 to that in 2008?
Keep it short and to the point. 0.98. What is the ratio of the Female students (as % of total students) in Yemen, Rep. in 2001 to that in 2008?
Provide a short and direct response. 0.8. What is the ratio of the Female students (as % of total students) of Fragile and conflict affected situations in 2001 to that in 2010?
Give a very brief answer. 0.95. What is the ratio of the Female students (as % of total students) of Nepal in 2001 to that in 2010?
Make the answer very short. 0.83. What is the ratio of the Female students (as % of total students) of Portugal in 2001 to that in 2010?
Keep it short and to the point. 0.99. What is the ratio of the Female students (as % of total students) in Yemen, Rep. in 2001 to that in 2010?
Your answer should be compact. 0.75. What is the ratio of the Female students (as % of total students) of Fragile and conflict affected situations in 2003 to that in 2004?
Your answer should be compact. 1.01. What is the ratio of the Female students (as % of total students) of Nepal in 2003 to that in 2004?
Your answer should be very brief. 0.96. What is the ratio of the Female students (as % of total students) in Portugal in 2003 to that in 2004?
Your answer should be compact. 0.98. What is the ratio of the Female students (as % of total students) of Yemen, Rep. in 2003 to that in 2004?
Provide a succinct answer. 0.97. What is the ratio of the Female students (as % of total students) of Fragile and conflict affected situations in 2003 to that in 2005?
Your response must be concise. 1. What is the ratio of the Female students (as % of total students) of Nepal in 2003 to that in 2005?
Offer a very short reply. 0.94. What is the ratio of the Female students (as % of total students) in Portugal in 2003 to that in 2005?
Provide a succinct answer. 0.98. What is the ratio of the Female students (as % of total students) of Yemen, Rep. in 2003 to that in 2005?
Ensure brevity in your answer.  0.94. What is the ratio of the Female students (as % of total students) of Fragile and conflict affected situations in 2003 to that in 2008?
Provide a succinct answer. 0.99. What is the ratio of the Female students (as % of total students) in Nepal in 2003 to that in 2008?
Make the answer very short. 0.89. What is the ratio of the Female students (as % of total students) of Portugal in 2003 to that in 2008?
Give a very brief answer. 0.99. What is the ratio of the Female students (as % of total students) in Yemen, Rep. in 2003 to that in 2008?
Give a very brief answer. 0.85. What is the ratio of the Female students (as % of total students) of Fragile and conflict affected situations in 2003 to that in 2010?
Give a very brief answer. 0.98. What is the ratio of the Female students (as % of total students) in Nepal in 2003 to that in 2010?
Give a very brief answer. 0.86. What is the ratio of the Female students (as % of total students) in Yemen, Rep. in 2003 to that in 2010?
Keep it short and to the point. 0.8. What is the ratio of the Female students (as % of total students) in Fragile and conflict affected situations in 2004 to that in 2005?
Your answer should be very brief. 0.99. What is the ratio of the Female students (as % of total students) of Nepal in 2004 to that in 2005?
Your answer should be very brief. 0.97. What is the ratio of the Female students (as % of total students) in Yemen, Rep. in 2004 to that in 2005?
Keep it short and to the point. 0.97. What is the ratio of the Female students (as % of total students) of Fragile and conflict affected situations in 2004 to that in 2008?
Ensure brevity in your answer.  0.98. What is the ratio of the Female students (as % of total students) in Nepal in 2004 to that in 2008?
Provide a succinct answer. 0.93. What is the ratio of the Female students (as % of total students) of Portugal in 2004 to that in 2008?
Your response must be concise. 1. What is the ratio of the Female students (as % of total students) of Yemen, Rep. in 2004 to that in 2008?
Your response must be concise. 0.88. What is the ratio of the Female students (as % of total students) of Fragile and conflict affected situations in 2004 to that in 2010?
Offer a terse response. 0.97. What is the ratio of the Female students (as % of total students) in Nepal in 2004 to that in 2010?
Ensure brevity in your answer.  0.89. What is the ratio of the Female students (as % of total students) of Portugal in 2004 to that in 2010?
Offer a very short reply. 1.01. What is the ratio of the Female students (as % of total students) of Yemen, Rep. in 2004 to that in 2010?
Your answer should be compact. 0.83. What is the ratio of the Female students (as % of total students) of Fragile and conflict affected situations in 2005 to that in 2008?
Your response must be concise. 0.99. What is the ratio of the Female students (as % of total students) of Nepal in 2005 to that in 2008?
Provide a short and direct response. 0.96. What is the ratio of the Female students (as % of total students) of Portugal in 2005 to that in 2008?
Provide a succinct answer. 1.01. What is the ratio of the Female students (as % of total students) in Yemen, Rep. in 2005 to that in 2008?
Keep it short and to the point. 0.91. What is the ratio of the Female students (as % of total students) in Fragile and conflict affected situations in 2005 to that in 2010?
Offer a terse response. 0.99. What is the ratio of the Female students (as % of total students) of Nepal in 2005 to that in 2010?
Your answer should be compact. 0.92. What is the ratio of the Female students (as % of total students) of Portugal in 2005 to that in 2010?
Offer a terse response. 1.02. What is the ratio of the Female students (as % of total students) in Yemen, Rep. in 2005 to that in 2010?
Your response must be concise. 0.86. What is the ratio of the Female students (as % of total students) in Fragile and conflict affected situations in 2008 to that in 2010?
Ensure brevity in your answer.  0.99. What is the ratio of the Female students (as % of total students) of Nepal in 2008 to that in 2010?
Provide a short and direct response. 0.96. What is the ratio of the Female students (as % of total students) of Portugal in 2008 to that in 2010?
Your answer should be compact. 1.01. What is the ratio of the Female students (as % of total students) of Yemen, Rep. in 2008 to that in 2010?
Offer a terse response. 0.94. What is the difference between the highest and the second highest Female students (as % of total students) in Fragile and conflict affected situations?
Keep it short and to the point. 0.31. What is the difference between the highest and the second highest Female students (as % of total students) in Nepal?
Keep it short and to the point. 1.93. What is the difference between the highest and the second highest Female students (as % of total students) of Portugal?
Make the answer very short. 0.28. What is the difference between the highest and the second highest Female students (as % of total students) of Yemen, Rep.?
Ensure brevity in your answer.  2.11. What is the difference between the highest and the lowest Female students (as % of total students) of Fragile and conflict affected situations?
Your answer should be compact. 2.06. What is the difference between the highest and the lowest Female students (as % of total students) in Nepal?
Offer a very short reply. 8.47. What is the difference between the highest and the lowest Female students (as % of total students) in Portugal?
Provide a short and direct response. 1.76. What is the difference between the highest and the lowest Female students (as % of total students) in Yemen, Rep.?
Offer a very short reply. 9.31. 